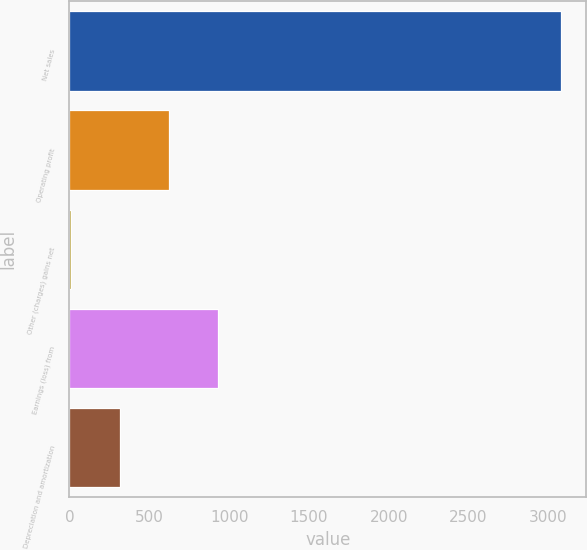Convert chart to OTSL. <chart><loc_0><loc_0><loc_500><loc_500><bar_chart><fcel>Net sales<fcel>Operating profit<fcel>Other (charges) gains net<fcel>Earnings (loss) from<fcel>Depreciation and amortization<nl><fcel>3082<fcel>626<fcel>12<fcel>933<fcel>319<nl></chart> 